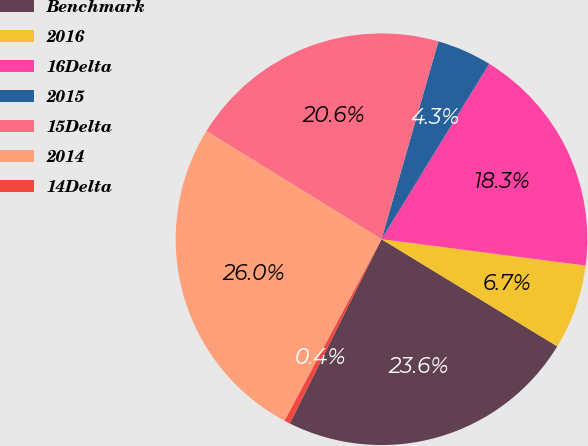Convert chart to OTSL. <chart><loc_0><loc_0><loc_500><loc_500><pie_chart><fcel>Benchmark<fcel>2016<fcel>16Delta<fcel>2015<fcel>15Delta<fcel>2014<fcel>14Delta<nl><fcel>23.64%<fcel>6.67%<fcel>18.28%<fcel>4.31%<fcel>20.65%<fcel>26.0%<fcel>0.45%<nl></chart> 